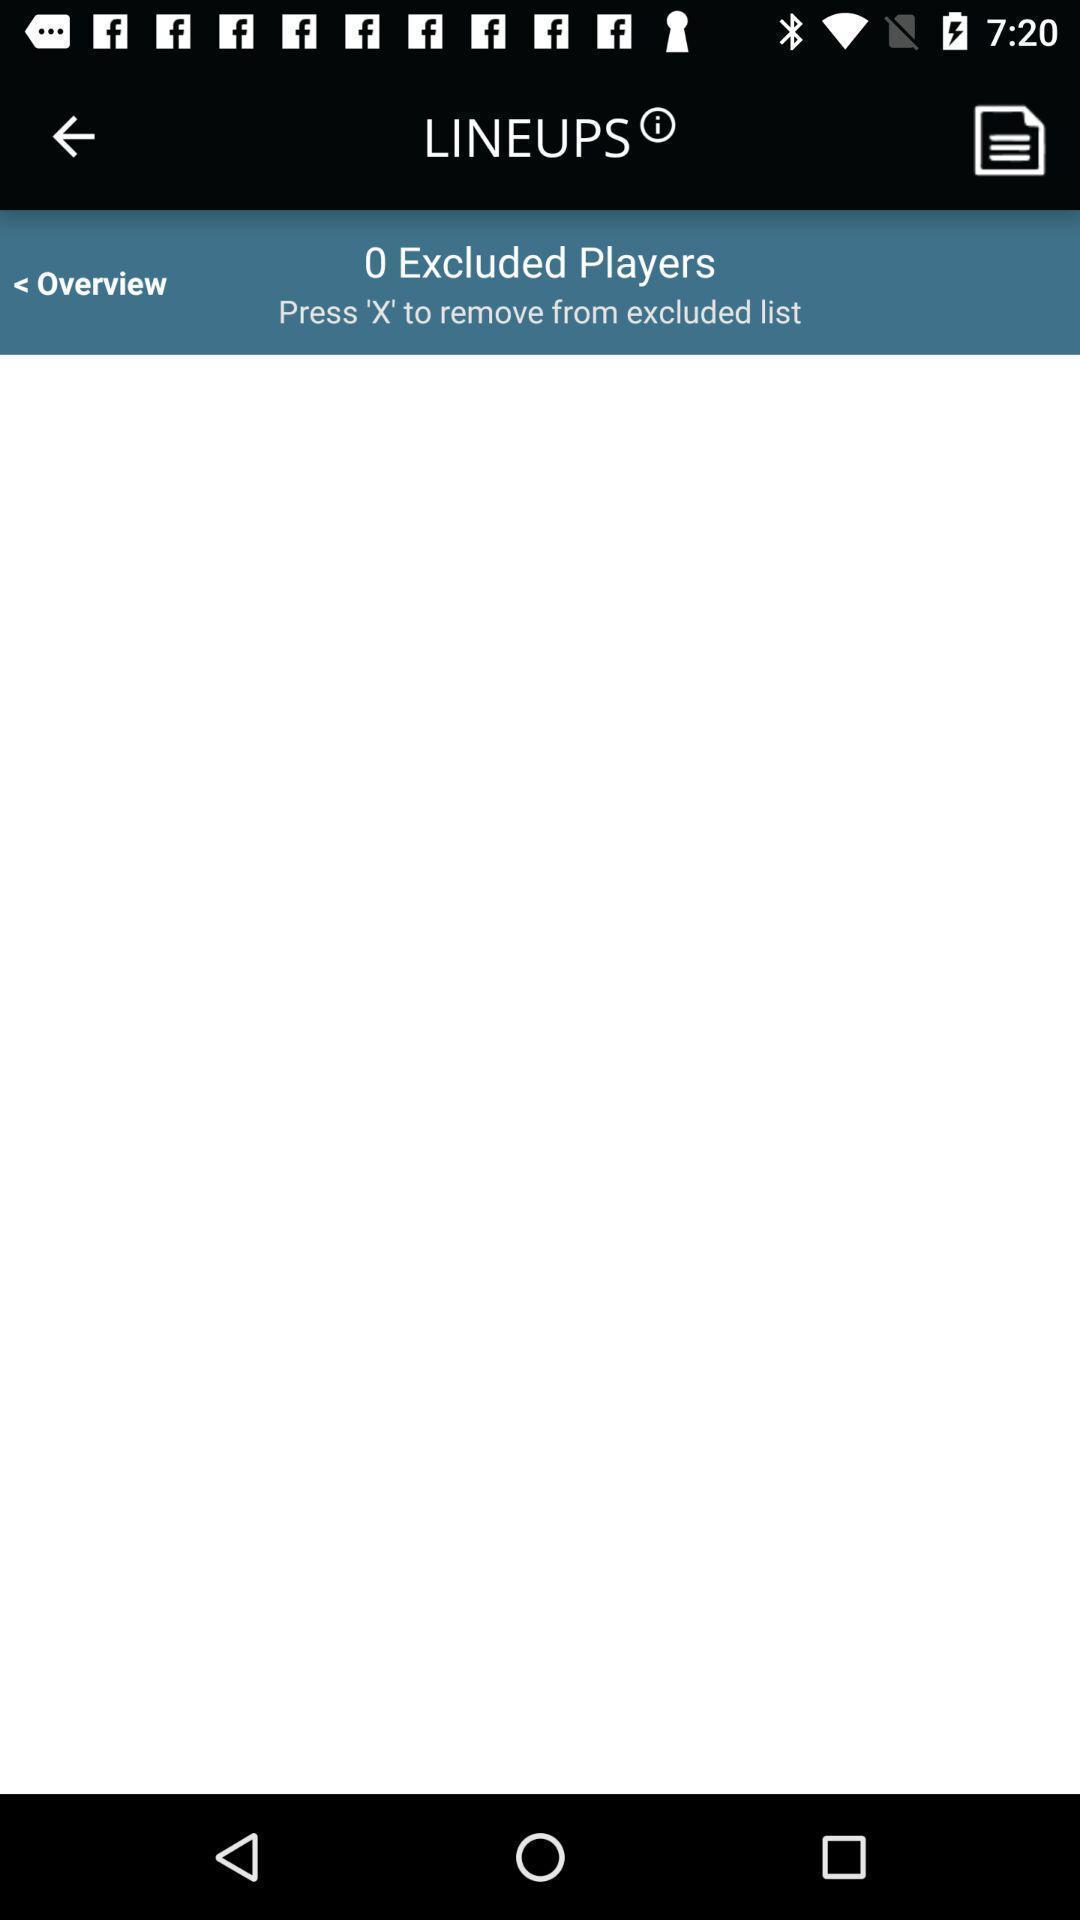Describe the key features of this screenshot. Page with options to remove excluded list. 